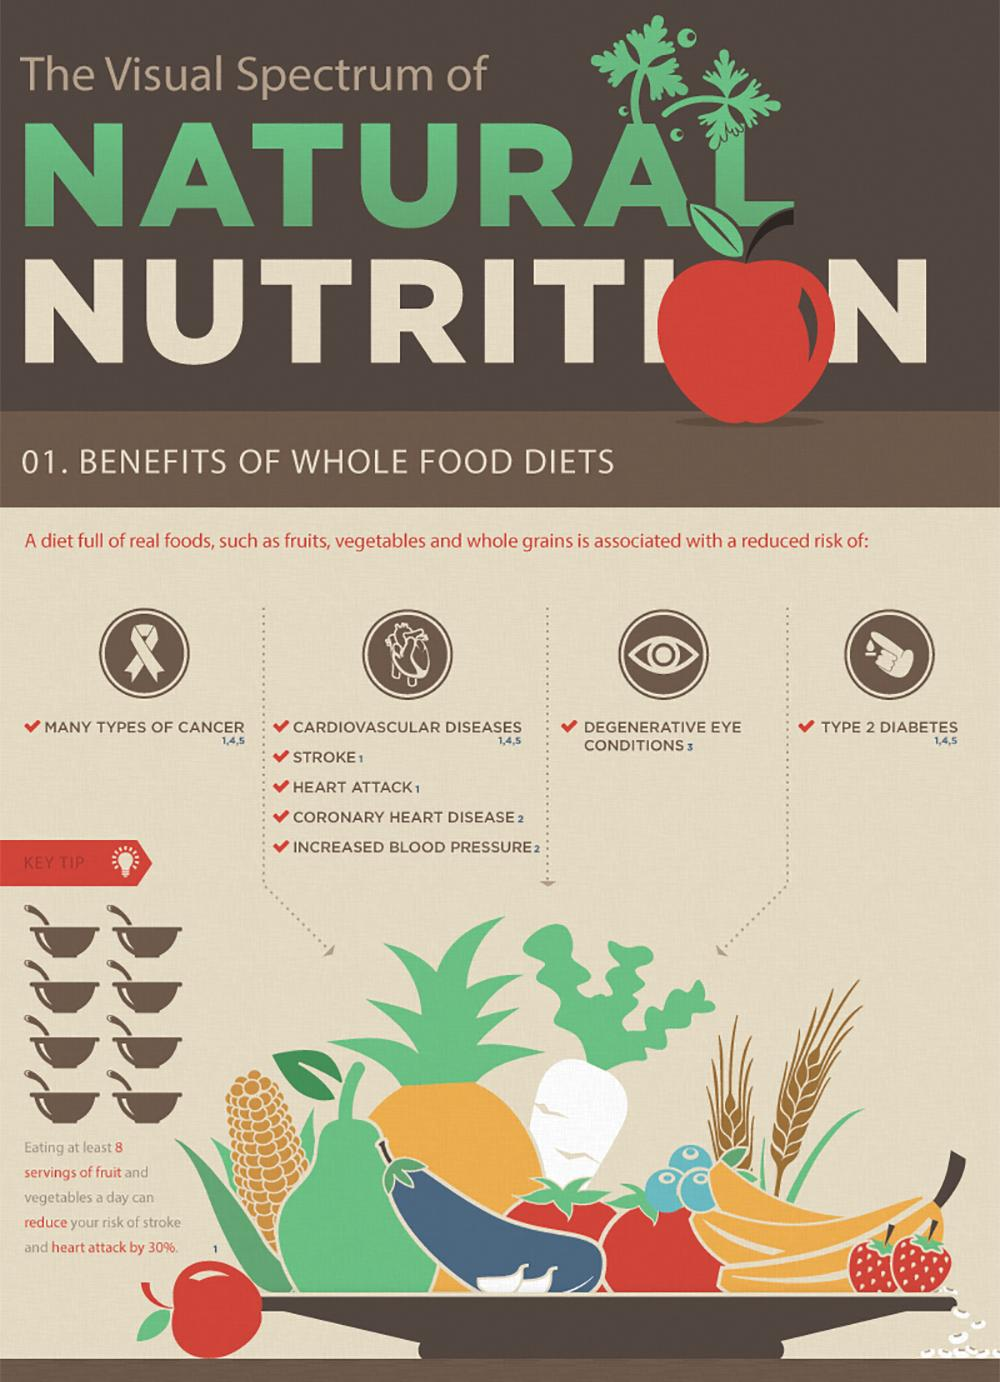Mention a couple of crucial points in this snapshot. Inadequate diet can lead to various health risks, particularly for the heart. Studies have linked a poor diet to an increased risk of heart disease, stroke, and other cardiovascular conditions. 